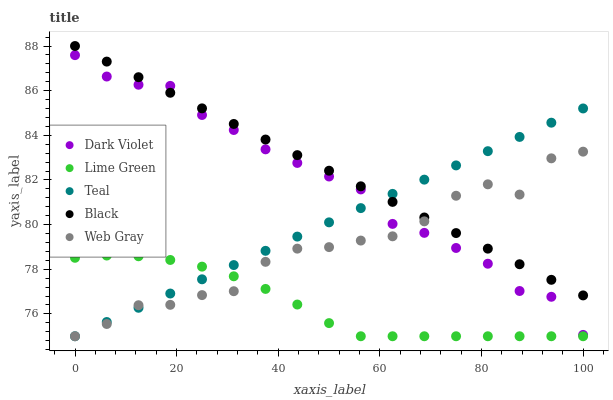Does Lime Green have the minimum area under the curve?
Answer yes or no. Yes. Does Black have the maximum area under the curve?
Answer yes or no. Yes. Does Web Gray have the minimum area under the curve?
Answer yes or no. No. Does Web Gray have the maximum area under the curve?
Answer yes or no. No. Is Black the smoothest?
Answer yes or no. Yes. Is Web Gray the roughest?
Answer yes or no. Yes. Is Lime Green the smoothest?
Answer yes or no. No. Is Lime Green the roughest?
Answer yes or no. No. Does Web Gray have the lowest value?
Answer yes or no. Yes. Does Dark Violet have the lowest value?
Answer yes or no. No. Does Black have the highest value?
Answer yes or no. Yes. Does Web Gray have the highest value?
Answer yes or no. No. Is Lime Green less than Black?
Answer yes or no. Yes. Is Dark Violet greater than Lime Green?
Answer yes or no. Yes. Does Dark Violet intersect Web Gray?
Answer yes or no. Yes. Is Dark Violet less than Web Gray?
Answer yes or no. No. Is Dark Violet greater than Web Gray?
Answer yes or no. No. Does Lime Green intersect Black?
Answer yes or no. No. 